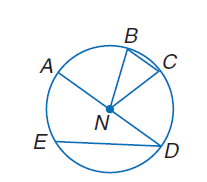Answer the mathemtical geometry problem and directly provide the correct option letter.
Question: If A D = 24, find C N.
Choices: A: 12 B: 36 C: 48 D: 60 A 